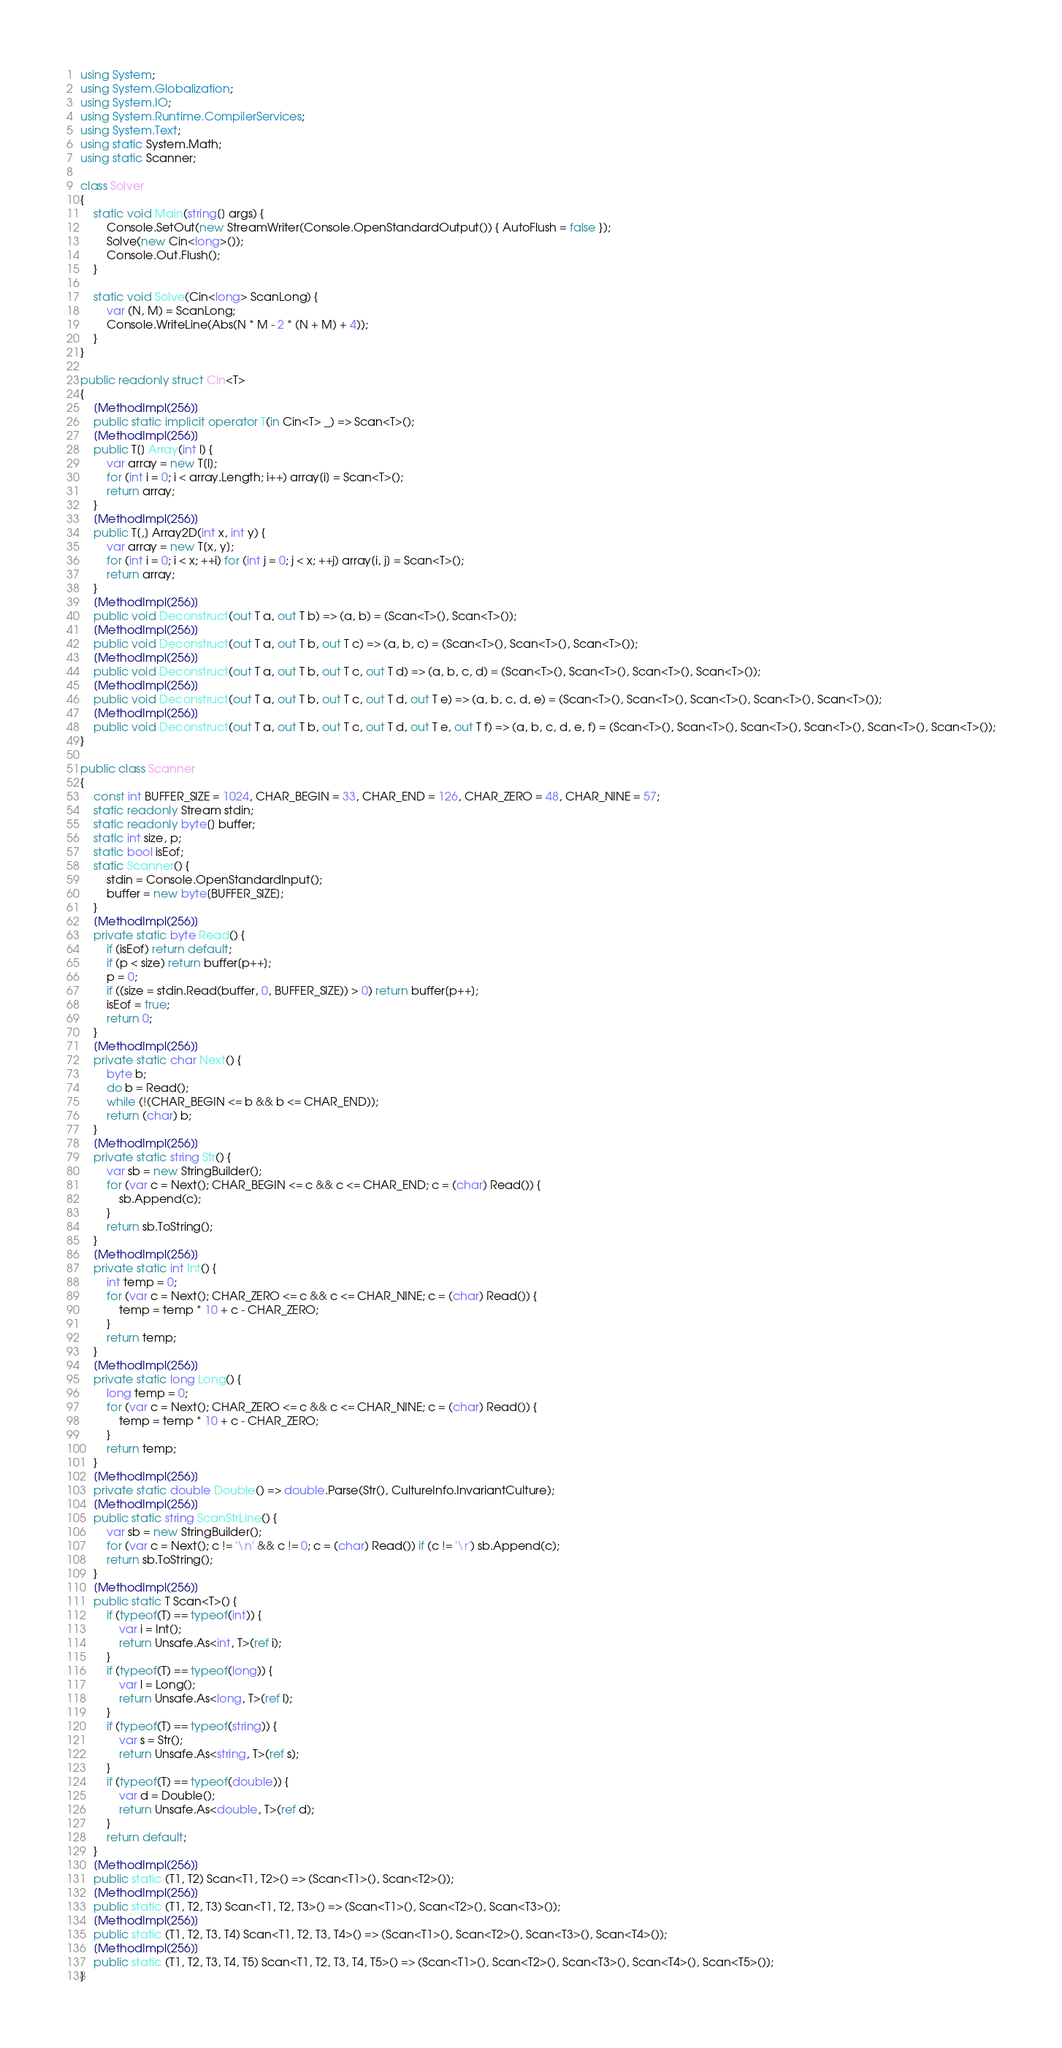Convert code to text. <code><loc_0><loc_0><loc_500><loc_500><_C#_>using System;
using System.Globalization;
using System.IO;
using System.Runtime.CompilerServices;
using System.Text;
using static System.Math;
using static Scanner;

class Solver
{
    static void Main(string[] args) {
        Console.SetOut(new StreamWriter(Console.OpenStandardOutput()) { AutoFlush = false });
        Solve(new Cin<long>());
        Console.Out.Flush();
    }

    static void Solve(Cin<long> ScanLong) {
        var (N, M) = ScanLong;
        Console.WriteLine(Abs(N * M - 2 * (N + M) + 4));
    }
}

public readonly struct Cin<T>
{
    [MethodImpl(256)]
    public static implicit operator T(in Cin<T> _) => Scan<T>();
    [MethodImpl(256)]
    public T[] Array(int l) {
        var array = new T[l];
        for (int i = 0; i < array.Length; i++) array[i] = Scan<T>();
        return array;
    }
    [MethodImpl(256)]
    public T[,] Array2D(int x, int y) {
        var array = new T[x, y];
        for (int i = 0; i < x; ++i) for (int j = 0; j < x; ++j) array[i, j] = Scan<T>();
        return array;
    }
    [MethodImpl(256)]
    public void Deconstruct(out T a, out T b) => (a, b) = (Scan<T>(), Scan<T>());
    [MethodImpl(256)]
    public void Deconstruct(out T a, out T b, out T c) => (a, b, c) = (Scan<T>(), Scan<T>(), Scan<T>());
    [MethodImpl(256)]
    public void Deconstruct(out T a, out T b, out T c, out T d) => (a, b, c, d) = (Scan<T>(), Scan<T>(), Scan<T>(), Scan<T>());
    [MethodImpl(256)]
    public void Deconstruct(out T a, out T b, out T c, out T d, out T e) => (a, b, c, d, e) = (Scan<T>(), Scan<T>(), Scan<T>(), Scan<T>(), Scan<T>());
    [MethodImpl(256)]
    public void Deconstruct(out T a, out T b, out T c, out T d, out T e, out T f) => (a, b, c, d, e, f) = (Scan<T>(), Scan<T>(), Scan<T>(), Scan<T>(), Scan<T>(), Scan<T>());
}

public class Scanner
{
    const int BUFFER_SIZE = 1024, CHAR_BEGIN = 33, CHAR_END = 126, CHAR_ZERO = 48, CHAR_NINE = 57;
    static readonly Stream stdin;
    static readonly byte[] buffer;
    static int size, p;
    static bool isEof;
    static Scanner() {
        stdin = Console.OpenStandardInput();
        buffer = new byte[BUFFER_SIZE];
    }
    [MethodImpl(256)]
    private static byte Read() {
        if (isEof) return default;
        if (p < size) return buffer[p++];
        p = 0;
        if ((size = stdin.Read(buffer, 0, BUFFER_SIZE)) > 0) return buffer[p++];
        isEof = true;
        return 0;
    }
    [MethodImpl(256)]
    private static char Next() {
        byte b;
        do b = Read();
        while (!(CHAR_BEGIN <= b && b <= CHAR_END));
        return (char) b;
    }
    [MethodImpl(256)]
    private static string Str() {
        var sb = new StringBuilder();
        for (var c = Next(); CHAR_BEGIN <= c && c <= CHAR_END; c = (char) Read()) {
            sb.Append(c);
        }
        return sb.ToString();
    }
    [MethodImpl(256)]
    private static int Int() {
        int temp = 0;
        for (var c = Next(); CHAR_ZERO <= c && c <= CHAR_NINE; c = (char) Read()) {
            temp = temp * 10 + c - CHAR_ZERO;
        }
        return temp;
    }
    [MethodImpl(256)]
    private static long Long() {
        long temp = 0;
        for (var c = Next(); CHAR_ZERO <= c && c <= CHAR_NINE; c = (char) Read()) {
            temp = temp * 10 + c - CHAR_ZERO;
        }
        return temp;
    }
    [MethodImpl(256)]
    private static double Double() => double.Parse(Str(), CultureInfo.InvariantCulture);
    [MethodImpl(256)]
    public static string ScanStrLine() {
        var sb = new StringBuilder();
        for (var c = Next(); c != '\n' && c != 0; c = (char) Read()) if (c != '\r') sb.Append(c);
        return sb.ToString();
    }
    [MethodImpl(256)]
    public static T Scan<T>() {
        if (typeof(T) == typeof(int)) {
            var i = Int();
            return Unsafe.As<int, T>(ref i);
        }
        if (typeof(T) == typeof(long)) {
            var l = Long();
            return Unsafe.As<long, T>(ref l);
        }
        if (typeof(T) == typeof(string)) {
            var s = Str();
            return Unsafe.As<string, T>(ref s);
        }
        if (typeof(T) == typeof(double)) {
            var d = Double();
            return Unsafe.As<double, T>(ref d);
        }
        return default;
    }
    [MethodImpl(256)]
    public static (T1, T2) Scan<T1, T2>() => (Scan<T1>(), Scan<T2>());
    [MethodImpl(256)]
    public static (T1, T2, T3) Scan<T1, T2, T3>() => (Scan<T1>(), Scan<T2>(), Scan<T3>());
    [MethodImpl(256)]
    public static (T1, T2, T3, T4) Scan<T1, T2, T3, T4>() => (Scan<T1>(), Scan<T2>(), Scan<T3>(), Scan<T4>());
    [MethodImpl(256)]
    public static (T1, T2, T3, T4, T5) Scan<T1, T2, T3, T4, T5>() => (Scan<T1>(), Scan<T2>(), Scan<T3>(), Scan<T4>(), Scan<T5>());
}</code> 